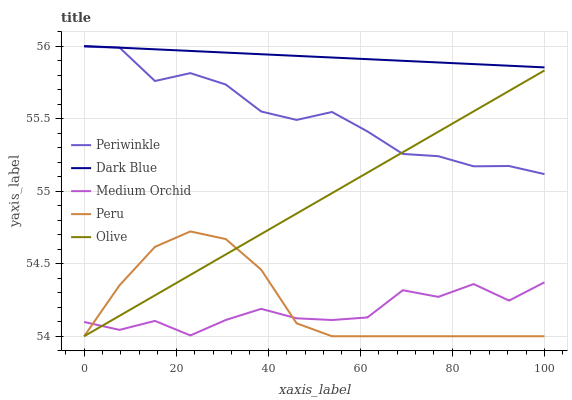Does Medium Orchid have the minimum area under the curve?
Answer yes or no. Yes. Does Dark Blue have the maximum area under the curve?
Answer yes or no. Yes. Does Dark Blue have the minimum area under the curve?
Answer yes or no. No. Does Medium Orchid have the maximum area under the curve?
Answer yes or no. No. Is Dark Blue the smoothest?
Answer yes or no. Yes. Is Medium Orchid the roughest?
Answer yes or no. Yes. Is Medium Orchid the smoothest?
Answer yes or no. No. Is Dark Blue the roughest?
Answer yes or no. No. Does Olive have the lowest value?
Answer yes or no. Yes. Does Medium Orchid have the lowest value?
Answer yes or no. No. Does Dark Blue have the highest value?
Answer yes or no. Yes. Does Medium Orchid have the highest value?
Answer yes or no. No. Is Olive less than Dark Blue?
Answer yes or no. Yes. Is Periwinkle greater than Medium Orchid?
Answer yes or no. Yes. Does Dark Blue intersect Periwinkle?
Answer yes or no. Yes. Is Dark Blue less than Periwinkle?
Answer yes or no. No. Is Dark Blue greater than Periwinkle?
Answer yes or no. No. Does Olive intersect Dark Blue?
Answer yes or no. No. 